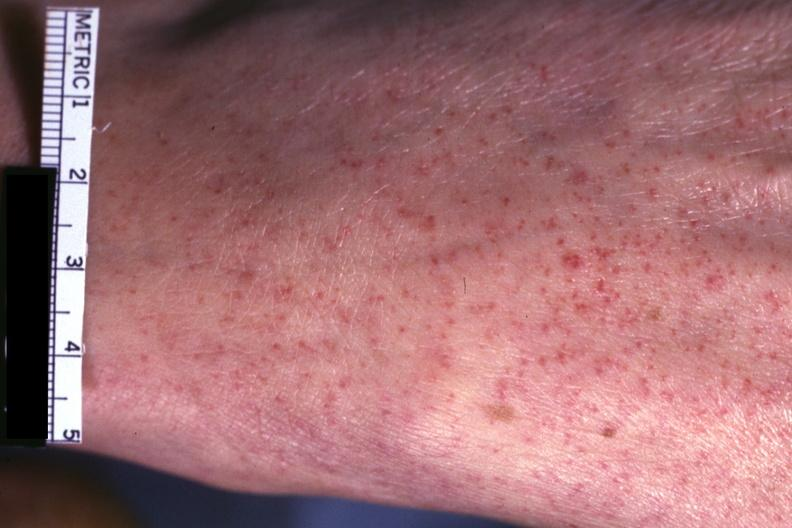what does this image show?
Answer the question using a single word or phrase. Good close-up of lesions 